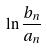Convert formula to latex. <formula><loc_0><loc_0><loc_500><loc_500>\ln \frac { b _ { n } } { a _ { n } }</formula> 